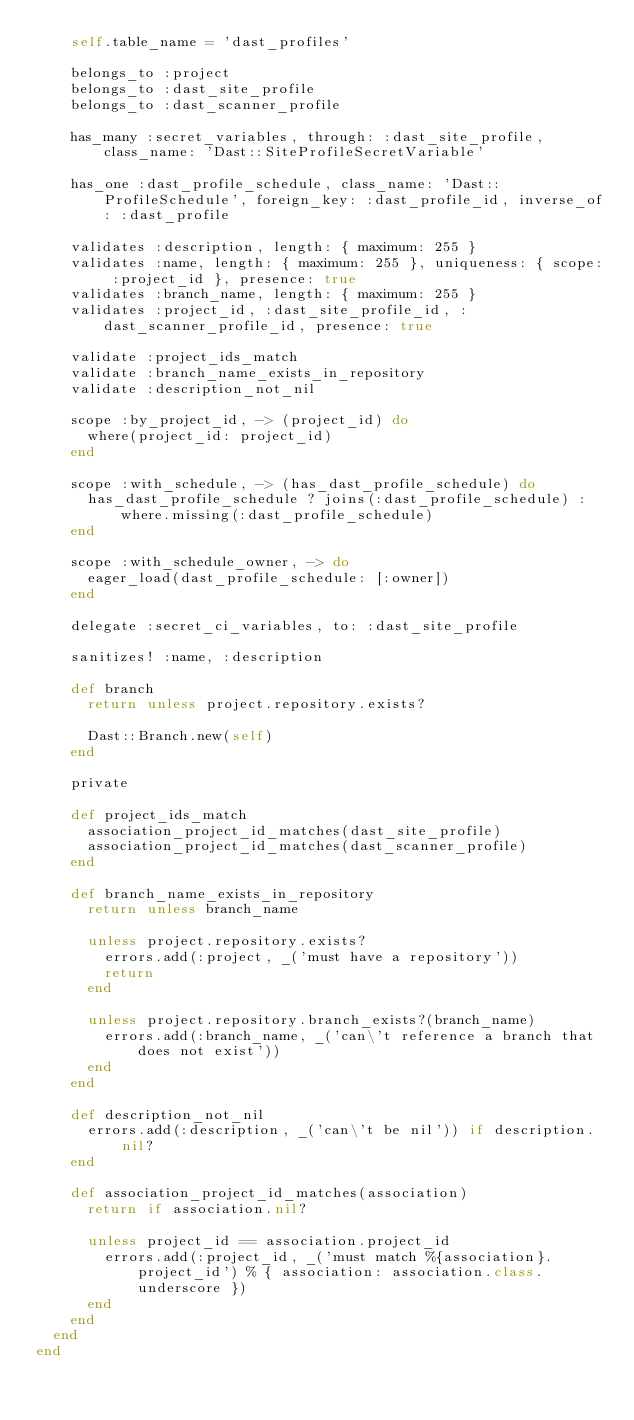Convert code to text. <code><loc_0><loc_0><loc_500><loc_500><_Ruby_>    self.table_name = 'dast_profiles'

    belongs_to :project
    belongs_to :dast_site_profile
    belongs_to :dast_scanner_profile

    has_many :secret_variables, through: :dast_site_profile, class_name: 'Dast::SiteProfileSecretVariable'

    has_one :dast_profile_schedule, class_name: 'Dast::ProfileSchedule', foreign_key: :dast_profile_id, inverse_of: :dast_profile

    validates :description, length: { maximum: 255 }
    validates :name, length: { maximum: 255 }, uniqueness: { scope: :project_id }, presence: true
    validates :branch_name, length: { maximum: 255 }
    validates :project_id, :dast_site_profile_id, :dast_scanner_profile_id, presence: true

    validate :project_ids_match
    validate :branch_name_exists_in_repository
    validate :description_not_nil

    scope :by_project_id, -> (project_id) do
      where(project_id: project_id)
    end

    scope :with_schedule, -> (has_dast_profile_schedule) do
      has_dast_profile_schedule ? joins(:dast_profile_schedule) : where.missing(:dast_profile_schedule)
    end

    scope :with_schedule_owner, -> do
      eager_load(dast_profile_schedule: [:owner])
    end

    delegate :secret_ci_variables, to: :dast_site_profile

    sanitizes! :name, :description

    def branch
      return unless project.repository.exists?

      Dast::Branch.new(self)
    end

    private

    def project_ids_match
      association_project_id_matches(dast_site_profile)
      association_project_id_matches(dast_scanner_profile)
    end

    def branch_name_exists_in_repository
      return unless branch_name

      unless project.repository.exists?
        errors.add(:project, _('must have a repository'))
        return
      end

      unless project.repository.branch_exists?(branch_name)
        errors.add(:branch_name, _('can\'t reference a branch that does not exist'))
      end
    end

    def description_not_nil
      errors.add(:description, _('can\'t be nil')) if description.nil?
    end

    def association_project_id_matches(association)
      return if association.nil?

      unless project_id == association.project_id
        errors.add(:project_id, _('must match %{association}.project_id') % { association: association.class.underscore })
      end
    end
  end
end
</code> 